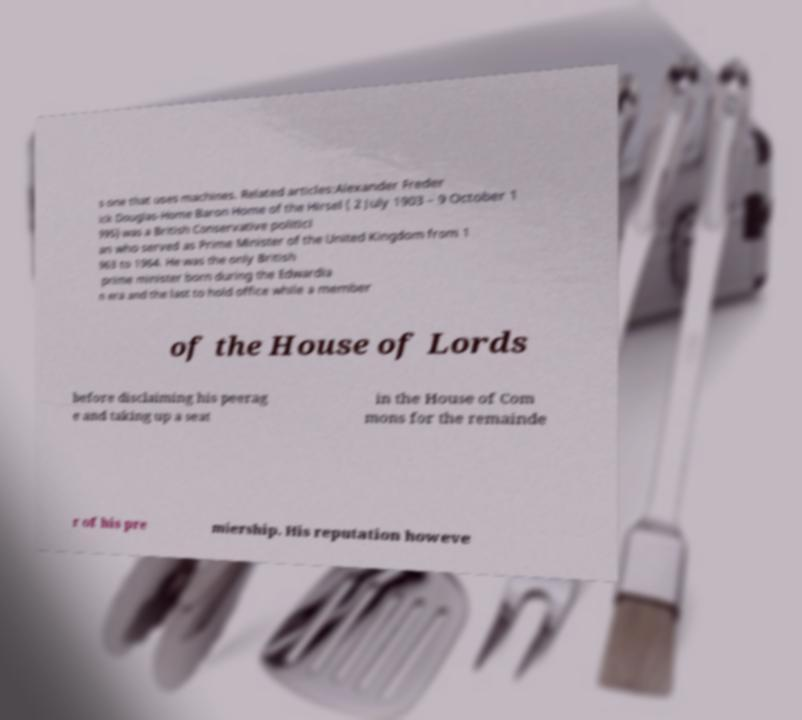Could you extract and type out the text from this image? s one that uses machines. Related articles:Alexander Freder ick Douglas-Home Baron Home of the Hirsel ( 2 July 1903 – 9 October 1 995) was a British Conservative politici an who served as Prime Minister of the United Kingdom from 1 963 to 1964. He was the only British prime minister born during the Edwardia n era and the last to hold office while a member of the House of Lords before disclaiming his peerag e and taking up a seat in the House of Com mons for the remainde r of his pre miership. His reputation howeve 